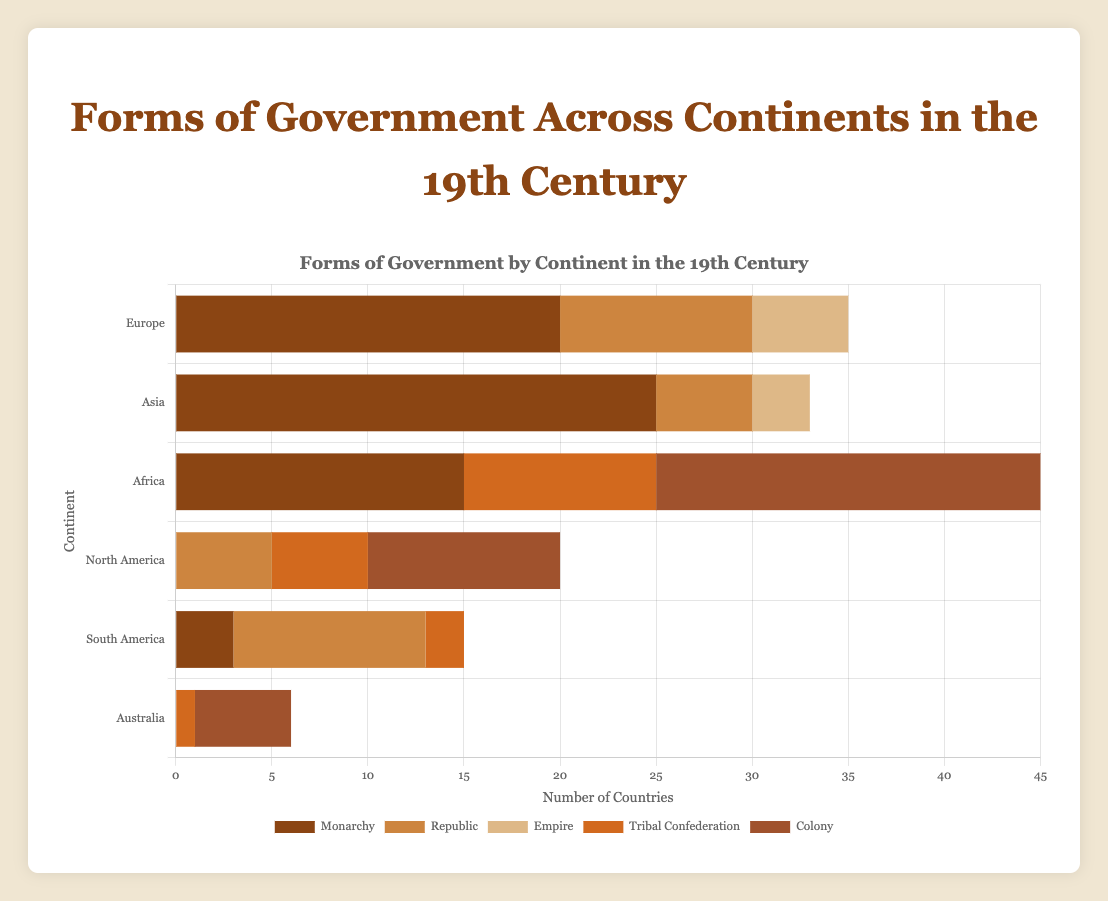Which continent had the highest number of Monarchies in the 19th century? The bar representing Monarchies in Asia is the tallest among all continents, specifically showing 25 countries. Hence, Asia had the highest number of Monarchies.
Answer: Asia How many continents had Republics as one of their forms of government? To find this, observe which continents have a bar for Republics. Republics are present in Europe, Asia, North America, and South America, totaling 4 continents.
Answer: 4 What is the total number of countries in Europe with either Monarchies or Empires? To find this, sum up the number of countries for Monarchies and Empires in Europe: 20 (Monarchies) + 5 (Empires) = 25.
Answer: 25 By how much does the number of Colonies in Africa exceed that in North America? The number of Colonies in Africa is 20, while in North America it is 10. The difference is 20 - 10 = 10.
Answer: 10 What is the most common form of government in Australia? The largest bar for Australia is for Colonies, which stands at 5 countries. Therefore, the most common form of government in Australia was Colonies.
Answer: Colony Which continent has the least diversity in forms of government? To determine this, count the different forms of government for each continent. Australia has the least diversity with only 2 forms (Colonies and Tribal Confederations).
Answer: Australia What is the combined number of countries in Australia and South America with Tribal Confederations? To find this, add the number of countries with Tribal Confederations in Australia (1) and South America (2): 1 + 2 = 3.
Answer: 3 Which form of government had more countries in Africa than in Europe? To see this, compare the bars for each form of government between Africa and Europe. Colonies had 20 countries in Africa and 0 in Europe, thus, Colonies is the form of government with more countries in Africa than Europe.
Answer: Colony 